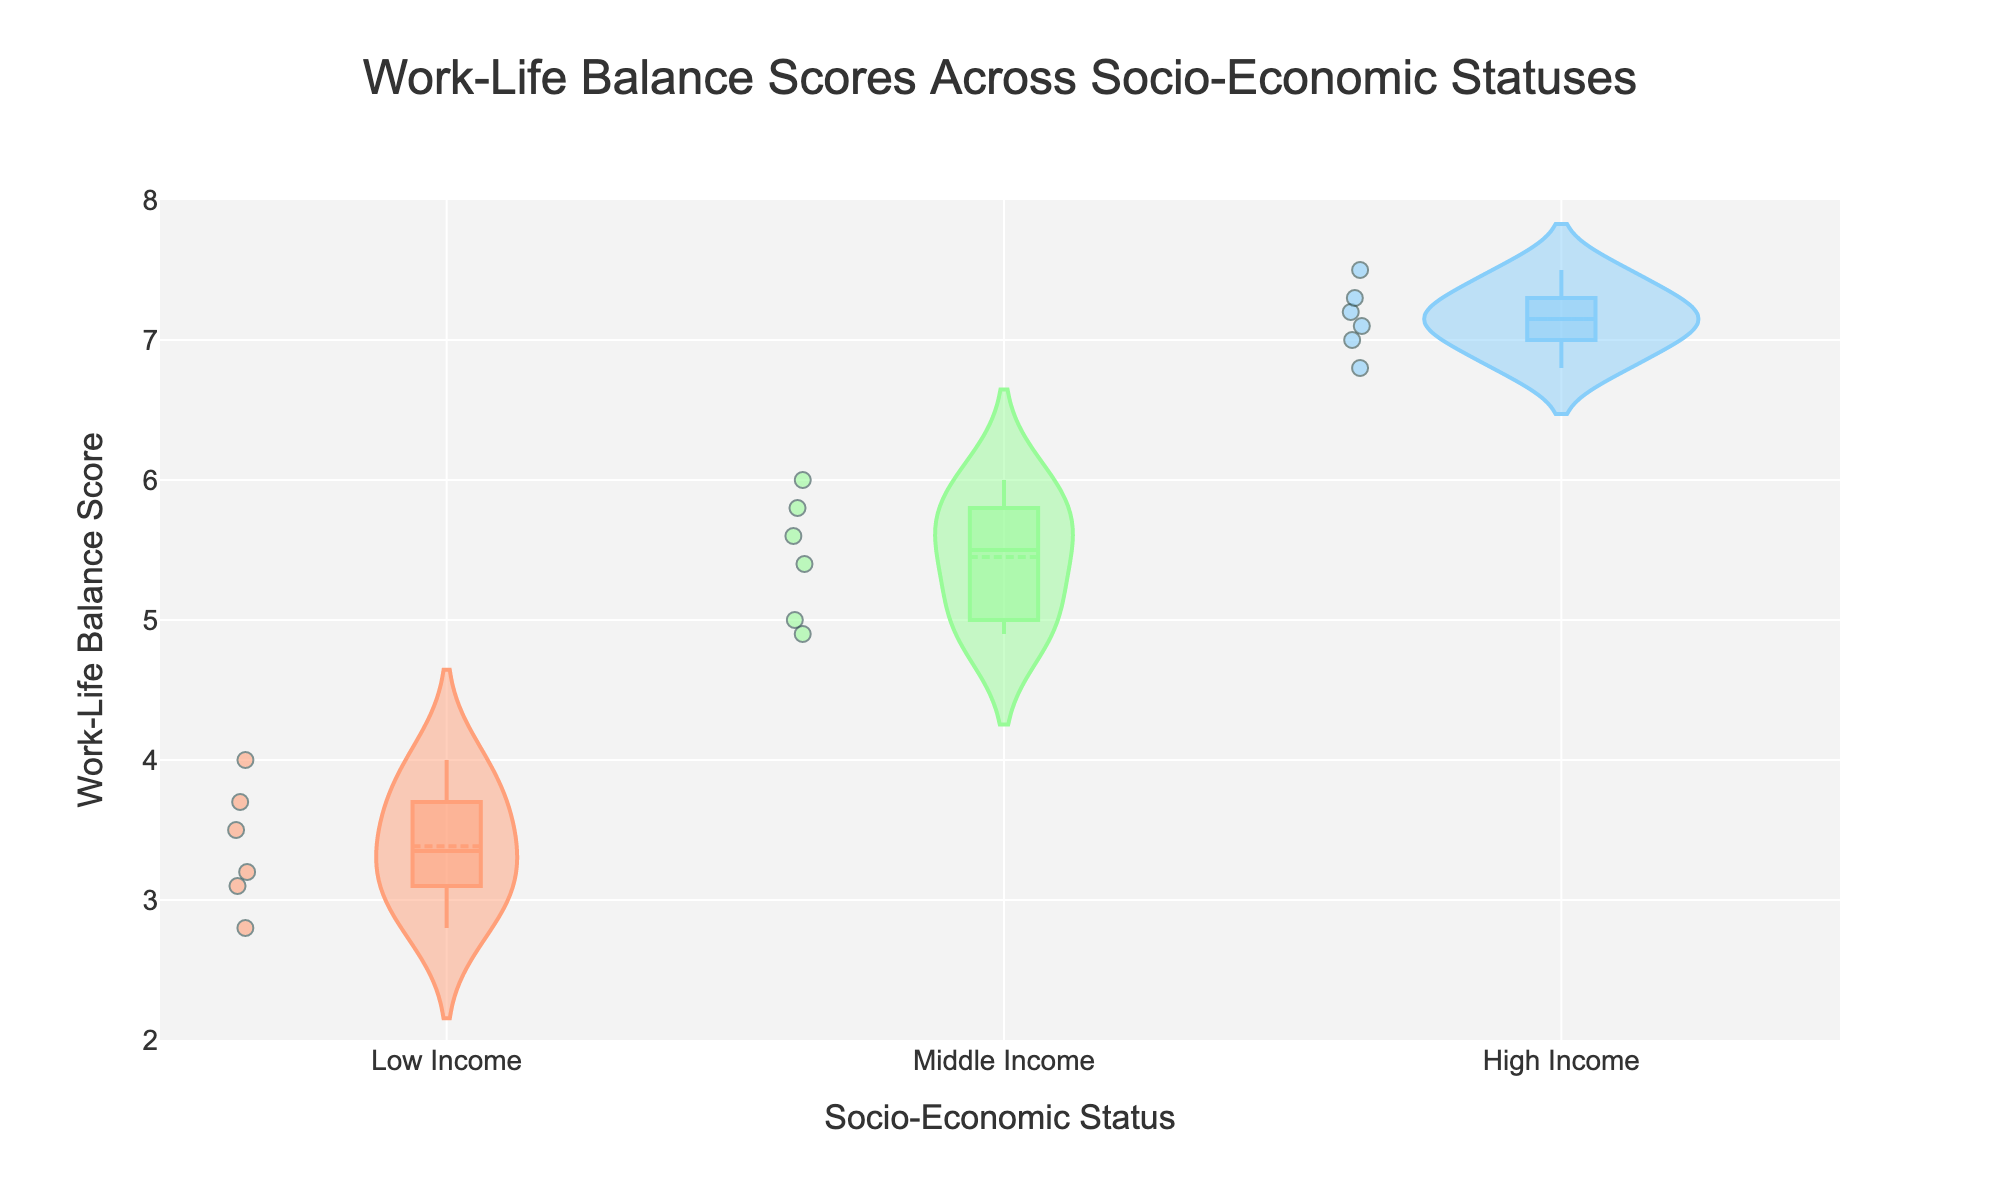What is the title of the plot? The title can be found at the top of the figure. It summarizes the data presented in the plot and provides context for the viewer to understand the chart.
Answer: Work-Life Balance Scores Across Socio-Economic Statuses What is the y-axis representing? The y-axis label is displayed along the vertical axis. It denotes the variable being measured.
Answer: Work-Life Balance Score How many socio-economic statuses are represented in the plot? The x-axis groups the data by different categories of socio-economic status. Each distinct category shown on the x-axis represents one socio-economic status.
Answer: Three Which socio-economic status shows the highest overall work-life balance score? To determine the highest overall work-life balance score, we look at the overall distribution and highest points in the violin plots across the socio-economic statuses. The highest segment of the violin plot indicates the highest score.
Answer: High Income What is the range of work-life balance scores for the Low Income group? The range can be identified by noting the minimum and maximum points within the violin plot for the Low Income group. The vertical span of the plot shows the distribution of scores.
Answer: 2.8 to 4.0 What is the median work-life balance score for the Middle Income group? The median value is represented by the line within the box plot that is overlaid on the violin plot. For the Middle Income group, this line can be found in the middle of the box plot.
Answer: Approximately 5.5 How does the spread of work-life balance scores compare between Middle Income and High Income groups? The spread is evaluated by comparing the width and vertical extent of the violin plots. Wider or taller plots indicate a larger spread.
Answer: The spread is larger in the High Income group than in the Middle Income group Which socio-economic status has the smallest range of work-life balance scores? By comparing the vertical extent of the violin plots for each socio-economic status, the group with the smallest vertical range has the smallest range of scores.
Answer: Low Income Is there any overlap in work-life balance scores between the Low Income and High Income groups? Overlap in scores would appear as regions where the violin plots for the two groups intersect along the y-axis. If there’s no direct intersection, we can infer from the ranges.
Answer: No How does the mean work-life balance score of the High Income group compare to that of the Low Income group? The mean score is indicated by a dashed line within each violin plot. Comparing the positions of these lines in the High Income and Low Income groups will reveal the difference in their means.
Answer: The mean score in the High Income group is higher 